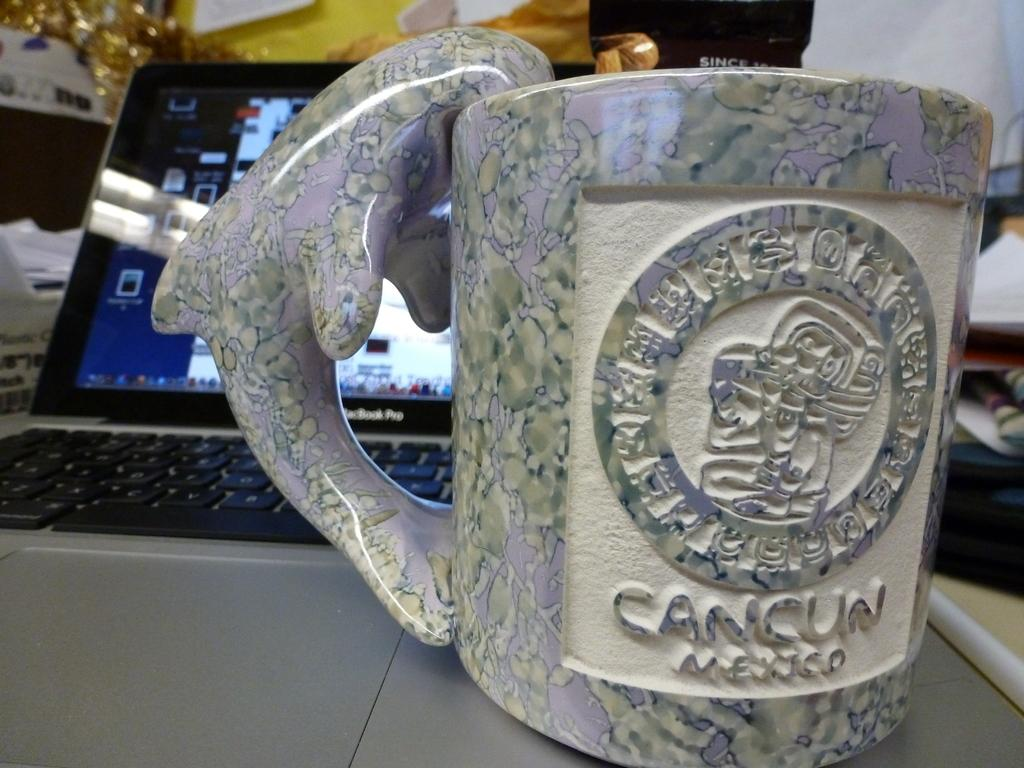Provide a one-sentence caption for the provided image. A souvenir mug from Cancun Mexico that has a dolphin handle. 